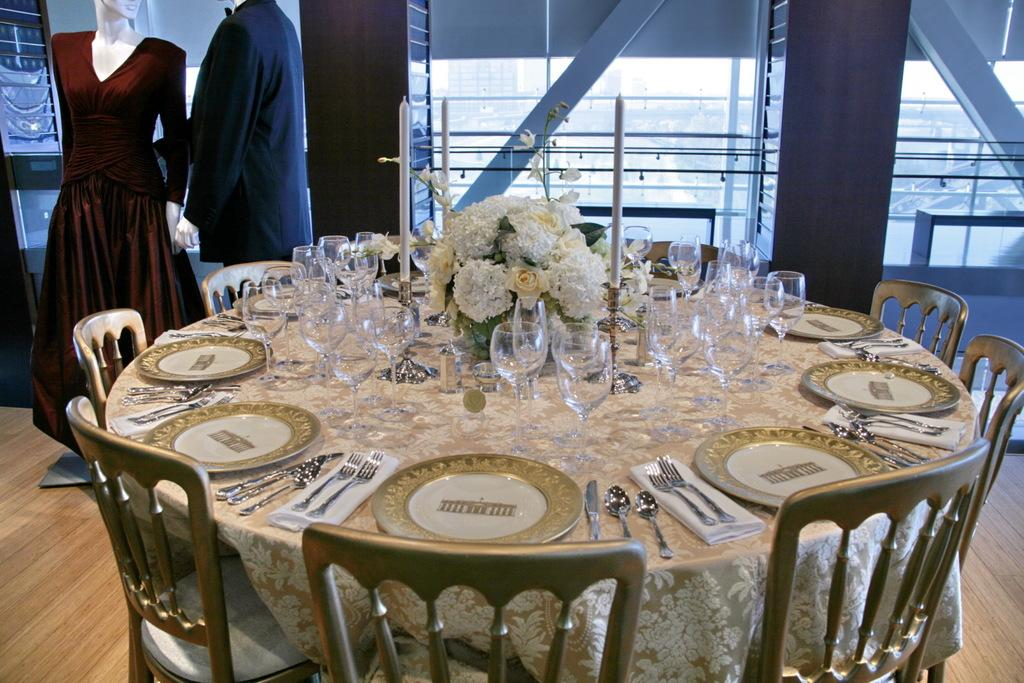What type of furniture is present in the image? There are chairs in the image. What items can be seen on the table in the image? There is a bouquet, glasses, plates, forks, knives, and spoons on the table in the image. Are there any toys visible in the image? Yes, there are two toys in the image. What type of hair can be seen on the table in the image? There is no hair present on the table in the image. What type of branch is visible in the image? There is no branch visible in the image. 